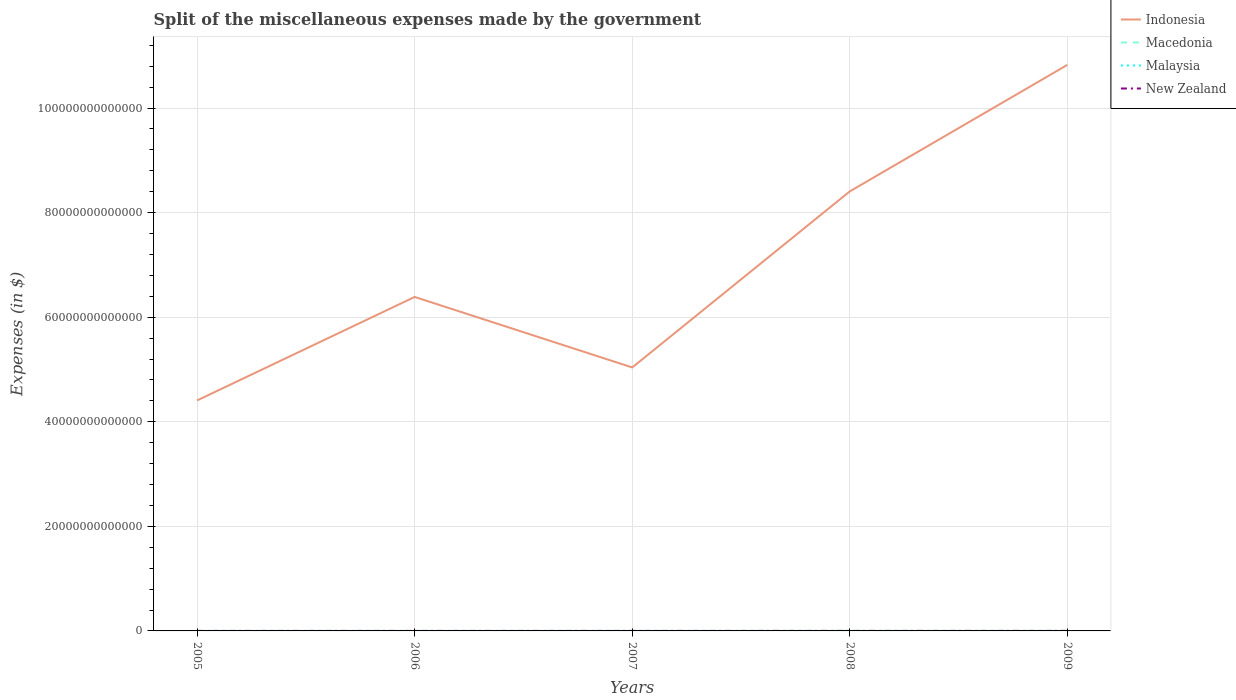Is the number of lines equal to the number of legend labels?
Make the answer very short. Yes. Across all years, what is the maximum miscellaneous expenses made by the government in New Zealand?
Your answer should be compact. 3.12e+09. In which year was the miscellaneous expenses made by the government in Macedonia maximum?
Ensure brevity in your answer.  2005. What is the total miscellaneous expenses made by the government in Indonesia in the graph?
Give a very brief answer. 1.35e+13. What is the difference between the highest and the second highest miscellaneous expenses made by the government in Malaysia?
Provide a succinct answer. 8.54e+08. How many lines are there?
Provide a short and direct response. 4. What is the difference between two consecutive major ticks on the Y-axis?
Give a very brief answer. 2.00e+13. What is the title of the graph?
Offer a terse response. Split of the miscellaneous expenses made by the government. What is the label or title of the Y-axis?
Offer a very short reply. Expenses (in $). What is the Expenses (in $) of Indonesia in 2005?
Give a very brief answer. 4.41e+13. What is the Expenses (in $) in Macedonia in 2005?
Make the answer very short. 2.39e+09. What is the Expenses (in $) of Malaysia in 2005?
Keep it short and to the point. 3.43e+08. What is the Expenses (in $) of New Zealand in 2005?
Ensure brevity in your answer.  3.12e+09. What is the Expenses (in $) in Indonesia in 2006?
Your answer should be very brief. 6.39e+13. What is the Expenses (in $) in Macedonia in 2006?
Offer a terse response. 2.82e+09. What is the Expenses (in $) in Malaysia in 2006?
Offer a very short reply. 3.91e+08. What is the Expenses (in $) in New Zealand in 2006?
Keep it short and to the point. 3.35e+09. What is the Expenses (in $) in Indonesia in 2007?
Provide a short and direct response. 5.04e+13. What is the Expenses (in $) in Macedonia in 2007?
Your response must be concise. 5.47e+09. What is the Expenses (in $) of Malaysia in 2007?
Your response must be concise. 1.20e+09. What is the Expenses (in $) of New Zealand in 2007?
Make the answer very short. 3.92e+09. What is the Expenses (in $) in Indonesia in 2008?
Your response must be concise. 8.41e+13. What is the Expenses (in $) in Macedonia in 2008?
Offer a terse response. 7.88e+09. What is the Expenses (in $) of Malaysia in 2008?
Your answer should be compact. 8.49e+08. What is the Expenses (in $) in New Zealand in 2008?
Ensure brevity in your answer.  4.79e+09. What is the Expenses (in $) of Indonesia in 2009?
Give a very brief answer. 1.08e+14. What is the Expenses (in $) of Macedonia in 2009?
Your response must be concise. 5.48e+09. What is the Expenses (in $) in Malaysia in 2009?
Provide a short and direct response. 6.85e+08. What is the Expenses (in $) in New Zealand in 2009?
Make the answer very short. 6.83e+09. Across all years, what is the maximum Expenses (in $) of Indonesia?
Provide a short and direct response. 1.08e+14. Across all years, what is the maximum Expenses (in $) in Macedonia?
Your answer should be compact. 7.88e+09. Across all years, what is the maximum Expenses (in $) of Malaysia?
Give a very brief answer. 1.20e+09. Across all years, what is the maximum Expenses (in $) of New Zealand?
Your answer should be compact. 6.83e+09. Across all years, what is the minimum Expenses (in $) of Indonesia?
Give a very brief answer. 4.41e+13. Across all years, what is the minimum Expenses (in $) in Macedonia?
Your answer should be very brief. 2.39e+09. Across all years, what is the minimum Expenses (in $) of Malaysia?
Offer a terse response. 3.43e+08. Across all years, what is the minimum Expenses (in $) of New Zealand?
Provide a succinct answer. 3.12e+09. What is the total Expenses (in $) of Indonesia in the graph?
Make the answer very short. 3.51e+14. What is the total Expenses (in $) of Macedonia in the graph?
Keep it short and to the point. 2.40e+1. What is the total Expenses (in $) of Malaysia in the graph?
Ensure brevity in your answer.  3.47e+09. What is the total Expenses (in $) of New Zealand in the graph?
Provide a succinct answer. 2.20e+1. What is the difference between the Expenses (in $) in Indonesia in 2005 and that in 2006?
Provide a succinct answer. -1.98e+13. What is the difference between the Expenses (in $) in Macedonia in 2005 and that in 2006?
Provide a short and direct response. -4.32e+08. What is the difference between the Expenses (in $) of Malaysia in 2005 and that in 2006?
Offer a terse response. -4.78e+07. What is the difference between the Expenses (in $) of New Zealand in 2005 and that in 2006?
Provide a succinct answer. -2.37e+08. What is the difference between the Expenses (in $) in Indonesia in 2005 and that in 2007?
Provide a succinct answer. -6.31e+12. What is the difference between the Expenses (in $) in Macedonia in 2005 and that in 2007?
Give a very brief answer. -3.08e+09. What is the difference between the Expenses (in $) of Malaysia in 2005 and that in 2007?
Your response must be concise. -8.54e+08. What is the difference between the Expenses (in $) of New Zealand in 2005 and that in 2007?
Make the answer very short. -8.05e+08. What is the difference between the Expenses (in $) in Indonesia in 2005 and that in 2008?
Provide a short and direct response. -4.00e+13. What is the difference between the Expenses (in $) in Macedonia in 2005 and that in 2008?
Your answer should be compact. -5.49e+09. What is the difference between the Expenses (in $) of Malaysia in 2005 and that in 2008?
Ensure brevity in your answer.  -5.06e+08. What is the difference between the Expenses (in $) in New Zealand in 2005 and that in 2008?
Your response must be concise. -1.68e+09. What is the difference between the Expenses (in $) of Indonesia in 2005 and that in 2009?
Provide a succinct answer. -6.42e+13. What is the difference between the Expenses (in $) in Macedonia in 2005 and that in 2009?
Provide a succinct answer. -3.09e+09. What is the difference between the Expenses (in $) of Malaysia in 2005 and that in 2009?
Give a very brief answer. -3.42e+08. What is the difference between the Expenses (in $) of New Zealand in 2005 and that in 2009?
Keep it short and to the point. -3.71e+09. What is the difference between the Expenses (in $) in Indonesia in 2006 and that in 2007?
Keep it short and to the point. 1.35e+13. What is the difference between the Expenses (in $) of Macedonia in 2006 and that in 2007?
Give a very brief answer. -2.65e+09. What is the difference between the Expenses (in $) of Malaysia in 2006 and that in 2007?
Your answer should be compact. -8.07e+08. What is the difference between the Expenses (in $) of New Zealand in 2006 and that in 2007?
Your answer should be very brief. -5.68e+08. What is the difference between the Expenses (in $) in Indonesia in 2006 and that in 2008?
Offer a terse response. -2.02e+13. What is the difference between the Expenses (in $) of Macedonia in 2006 and that in 2008?
Offer a terse response. -5.06e+09. What is the difference between the Expenses (in $) of Malaysia in 2006 and that in 2008?
Give a very brief answer. -4.58e+08. What is the difference between the Expenses (in $) of New Zealand in 2006 and that in 2008?
Ensure brevity in your answer.  -1.44e+09. What is the difference between the Expenses (in $) of Indonesia in 2006 and that in 2009?
Make the answer very short. -4.44e+13. What is the difference between the Expenses (in $) of Macedonia in 2006 and that in 2009?
Offer a terse response. -2.66e+09. What is the difference between the Expenses (in $) of Malaysia in 2006 and that in 2009?
Your answer should be compact. -2.94e+08. What is the difference between the Expenses (in $) in New Zealand in 2006 and that in 2009?
Your answer should be compact. -3.48e+09. What is the difference between the Expenses (in $) in Indonesia in 2007 and that in 2008?
Your answer should be very brief. -3.37e+13. What is the difference between the Expenses (in $) of Macedonia in 2007 and that in 2008?
Ensure brevity in your answer.  -2.41e+09. What is the difference between the Expenses (in $) of Malaysia in 2007 and that in 2008?
Your answer should be very brief. 3.48e+08. What is the difference between the Expenses (in $) of New Zealand in 2007 and that in 2008?
Your response must be concise. -8.73e+08. What is the difference between the Expenses (in $) of Indonesia in 2007 and that in 2009?
Your answer should be very brief. -5.79e+13. What is the difference between the Expenses (in $) of Macedonia in 2007 and that in 2009?
Provide a short and direct response. -1.40e+07. What is the difference between the Expenses (in $) of Malaysia in 2007 and that in 2009?
Keep it short and to the point. 5.12e+08. What is the difference between the Expenses (in $) in New Zealand in 2007 and that in 2009?
Make the answer very short. -2.91e+09. What is the difference between the Expenses (in $) in Indonesia in 2008 and that in 2009?
Your answer should be compact. -2.42e+13. What is the difference between the Expenses (in $) in Macedonia in 2008 and that in 2009?
Provide a short and direct response. 2.40e+09. What is the difference between the Expenses (in $) in Malaysia in 2008 and that in 2009?
Offer a terse response. 1.64e+08. What is the difference between the Expenses (in $) of New Zealand in 2008 and that in 2009?
Your answer should be very brief. -2.04e+09. What is the difference between the Expenses (in $) of Indonesia in 2005 and the Expenses (in $) of Macedonia in 2006?
Your response must be concise. 4.41e+13. What is the difference between the Expenses (in $) in Indonesia in 2005 and the Expenses (in $) in Malaysia in 2006?
Your response must be concise. 4.41e+13. What is the difference between the Expenses (in $) of Indonesia in 2005 and the Expenses (in $) of New Zealand in 2006?
Your response must be concise. 4.41e+13. What is the difference between the Expenses (in $) in Macedonia in 2005 and the Expenses (in $) in Malaysia in 2006?
Make the answer very short. 2.00e+09. What is the difference between the Expenses (in $) in Macedonia in 2005 and the Expenses (in $) in New Zealand in 2006?
Offer a terse response. -9.66e+08. What is the difference between the Expenses (in $) in Malaysia in 2005 and the Expenses (in $) in New Zealand in 2006?
Offer a terse response. -3.01e+09. What is the difference between the Expenses (in $) of Indonesia in 2005 and the Expenses (in $) of Macedonia in 2007?
Offer a very short reply. 4.41e+13. What is the difference between the Expenses (in $) in Indonesia in 2005 and the Expenses (in $) in Malaysia in 2007?
Offer a very short reply. 4.41e+13. What is the difference between the Expenses (in $) in Indonesia in 2005 and the Expenses (in $) in New Zealand in 2007?
Keep it short and to the point. 4.41e+13. What is the difference between the Expenses (in $) in Macedonia in 2005 and the Expenses (in $) in Malaysia in 2007?
Your answer should be compact. 1.19e+09. What is the difference between the Expenses (in $) in Macedonia in 2005 and the Expenses (in $) in New Zealand in 2007?
Give a very brief answer. -1.53e+09. What is the difference between the Expenses (in $) in Malaysia in 2005 and the Expenses (in $) in New Zealand in 2007?
Keep it short and to the point. -3.58e+09. What is the difference between the Expenses (in $) of Indonesia in 2005 and the Expenses (in $) of Macedonia in 2008?
Provide a short and direct response. 4.41e+13. What is the difference between the Expenses (in $) of Indonesia in 2005 and the Expenses (in $) of Malaysia in 2008?
Keep it short and to the point. 4.41e+13. What is the difference between the Expenses (in $) in Indonesia in 2005 and the Expenses (in $) in New Zealand in 2008?
Provide a short and direct response. 4.41e+13. What is the difference between the Expenses (in $) in Macedonia in 2005 and the Expenses (in $) in Malaysia in 2008?
Provide a succinct answer. 1.54e+09. What is the difference between the Expenses (in $) in Macedonia in 2005 and the Expenses (in $) in New Zealand in 2008?
Offer a terse response. -2.41e+09. What is the difference between the Expenses (in $) of Malaysia in 2005 and the Expenses (in $) of New Zealand in 2008?
Make the answer very short. -4.45e+09. What is the difference between the Expenses (in $) in Indonesia in 2005 and the Expenses (in $) in Macedonia in 2009?
Ensure brevity in your answer.  4.41e+13. What is the difference between the Expenses (in $) of Indonesia in 2005 and the Expenses (in $) of Malaysia in 2009?
Provide a short and direct response. 4.41e+13. What is the difference between the Expenses (in $) in Indonesia in 2005 and the Expenses (in $) in New Zealand in 2009?
Your answer should be compact. 4.41e+13. What is the difference between the Expenses (in $) in Macedonia in 2005 and the Expenses (in $) in Malaysia in 2009?
Keep it short and to the point. 1.70e+09. What is the difference between the Expenses (in $) in Macedonia in 2005 and the Expenses (in $) in New Zealand in 2009?
Keep it short and to the point. -4.44e+09. What is the difference between the Expenses (in $) in Malaysia in 2005 and the Expenses (in $) in New Zealand in 2009?
Your answer should be compact. -6.49e+09. What is the difference between the Expenses (in $) of Indonesia in 2006 and the Expenses (in $) of Macedonia in 2007?
Offer a terse response. 6.39e+13. What is the difference between the Expenses (in $) in Indonesia in 2006 and the Expenses (in $) in Malaysia in 2007?
Provide a succinct answer. 6.39e+13. What is the difference between the Expenses (in $) in Indonesia in 2006 and the Expenses (in $) in New Zealand in 2007?
Your answer should be compact. 6.39e+13. What is the difference between the Expenses (in $) of Macedonia in 2006 and the Expenses (in $) of Malaysia in 2007?
Offer a terse response. 1.62e+09. What is the difference between the Expenses (in $) in Macedonia in 2006 and the Expenses (in $) in New Zealand in 2007?
Offer a very short reply. -1.10e+09. What is the difference between the Expenses (in $) of Malaysia in 2006 and the Expenses (in $) of New Zealand in 2007?
Ensure brevity in your answer.  -3.53e+09. What is the difference between the Expenses (in $) in Indonesia in 2006 and the Expenses (in $) in Macedonia in 2008?
Provide a succinct answer. 6.39e+13. What is the difference between the Expenses (in $) of Indonesia in 2006 and the Expenses (in $) of Malaysia in 2008?
Offer a very short reply. 6.39e+13. What is the difference between the Expenses (in $) of Indonesia in 2006 and the Expenses (in $) of New Zealand in 2008?
Your response must be concise. 6.39e+13. What is the difference between the Expenses (in $) in Macedonia in 2006 and the Expenses (in $) in Malaysia in 2008?
Provide a succinct answer. 1.97e+09. What is the difference between the Expenses (in $) in Macedonia in 2006 and the Expenses (in $) in New Zealand in 2008?
Provide a succinct answer. -1.97e+09. What is the difference between the Expenses (in $) of Malaysia in 2006 and the Expenses (in $) of New Zealand in 2008?
Make the answer very short. -4.40e+09. What is the difference between the Expenses (in $) of Indonesia in 2006 and the Expenses (in $) of Macedonia in 2009?
Your answer should be compact. 6.39e+13. What is the difference between the Expenses (in $) in Indonesia in 2006 and the Expenses (in $) in Malaysia in 2009?
Your response must be concise. 6.39e+13. What is the difference between the Expenses (in $) of Indonesia in 2006 and the Expenses (in $) of New Zealand in 2009?
Provide a short and direct response. 6.39e+13. What is the difference between the Expenses (in $) in Macedonia in 2006 and the Expenses (in $) in Malaysia in 2009?
Your response must be concise. 2.13e+09. What is the difference between the Expenses (in $) in Macedonia in 2006 and the Expenses (in $) in New Zealand in 2009?
Make the answer very short. -4.01e+09. What is the difference between the Expenses (in $) of Malaysia in 2006 and the Expenses (in $) of New Zealand in 2009?
Provide a short and direct response. -6.44e+09. What is the difference between the Expenses (in $) of Indonesia in 2007 and the Expenses (in $) of Macedonia in 2008?
Provide a succinct answer. 5.04e+13. What is the difference between the Expenses (in $) in Indonesia in 2007 and the Expenses (in $) in Malaysia in 2008?
Give a very brief answer. 5.04e+13. What is the difference between the Expenses (in $) in Indonesia in 2007 and the Expenses (in $) in New Zealand in 2008?
Keep it short and to the point. 5.04e+13. What is the difference between the Expenses (in $) in Macedonia in 2007 and the Expenses (in $) in Malaysia in 2008?
Provide a short and direct response. 4.62e+09. What is the difference between the Expenses (in $) of Macedonia in 2007 and the Expenses (in $) of New Zealand in 2008?
Provide a succinct answer. 6.73e+08. What is the difference between the Expenses (in $) of Malaysia in 2007 and the Expenses (in $) of New Zealand in 2008?
Offer a terse response. -3.60e+09. What is the difference between the Expenses (in $) in Indonesia in 2007 and the Expenses (in $) in Macedonia in 2009?
Provide a succinct answer. 5.04e+13. What is the difference between the Expenses (in $) of Indonesia in 2007 and the Expenses (in $) of Malaysia in 2009?
Offer a terse response. 5.04e+13. What is the difference between the Expenses (in $) in Indonesia in 2007 and the Expenses (in $) in New Zealand in 2009?
Offer a terse response. 5.04e+13. What is the difference between the Expenses (in $) in Macedonia in 2007 and the Expenses (in $) in Malaysia in 2009?
Provide a succinct answer. 4.78e+09. What is the difference between the Expenses (in $) in Macedonia in 2007 and the Expenses (in $) in New Zealand in 2009?
Offer a terse response. -1.36e+09. What is the difference between the Expenses (in $) of Malaysia in 2007 and the Expenses (in $) of New Zealand in 2009?
Your answer should be very brief. -5.63e+09. What is the difference between the Expenses (in $) in Indonesia in 2008 and the Expenses (in $) in Macedonia in 2009?
Your answer should be very brief. 8.41e+13. What is the difference between the Expenses (in $) of Indonesia in 2008 and the Expenses (in $) of Malaysia in 2009?
Your response must be concise. 8.41e+13. What is the difference between the Expenses (in $) in Indonesia in 2008 and the Expenses (in $) in New Zealand in 2009?
Make the answer very short. 8.41e+13. What is the difference between the Expenses (in $) of Macedonia in 2008 and the Expenses (in $) of Malaysia in 2009?
Your response must be concise. 7.19e+09. What is the difference between the Expenses (in $) of Macedonia in 2008 and the Expenses (in $) of New Zealand in 2009?
Your answer should be very brief. 1.05e+09. What is the difference between the Expenses (in $) in Malaysia in 2008 and the Expenses (in $) in New Zealand in 2009?
Offer a terse response. -5.98e+09. What is the average Expenses (in $) of Indonesia per year?
Make the answer very short. 7.01e+13. What is the average Expenses (in $) in Macedonia per year?
Provide a short and direct response. 4.81e+09. What is the average Expenses (in $) of Malaysia per year?
Your answer should be very brief. 6.93e+08. What is the average Expenses (in $) of New Zealand per year?
Offer a very short reply. 4.40e+09. In the year 2005, what is the difference between the Expenses (in $) of Indonesia and Expenses (in $) of Macedonia?
Offer a terse response. 4.41e+13. In the year 2005, what is the difference between the Expenses (in $) in Indonesia and Expenses (in $) in Malaysia?
Keep it short and to the point. 4.41e+13. In the year 2005, what is the difference between the Expenses (in $) in Indonesia and Expenses (in $) in New Zealand?
Provide a succinct answer. 4.41e+13. In the year 2005, what is the difference between the Expenses (in $) of Macedonia and Expenses (in $) of Malaysia?
Provide a succinct answer. 2.04e+09. In the year 2005, what is the difference between the Expenses (in $) in Macedonia and Expenses (in $) in New Zealand?
Offer a very short reply. -7.29e+08. In the year 2005, what is the difference between the Expenses (in $) of Malaysia and Expenses (in $) of New Zealand?
Give a very brief answer. -2.77e+09. In the year 2006, what is the difference between the Expenses (in $) of Indonesia and Expenses (in $) of Macedonia?
Give a very brief answer. 6.39e+13. In the year 2006, what is the difference between the Expenses (in $) in Indonesia and Expenses (in $) in Malaysia?
Provide a succinct answer. 6.39e+13. In the year 2006, what is the difference between the Expenses (in $) in Indonesia and Expenses (in $) in New Zealand?
Give a very brief answer. 6.39e+13. In the year 2006, what is the difference between the Expenses (in $) of Macedonia and Expenses (in $) of Malaysia?
Provide a succinct answer. 2.43e+09. In the year 2006, what is the difference between the Expenses (in $) in Macedonia and Expenses (in $) in New Zealand?
Provide a short and direct response. -5.33e+08. In the year 2006, what is the difference between the Expenses (in $) of Malaysia and Expenses (in $) of New Zealand?
Your answer should be compact. -2.96e+09. In the year 2007, what is the difference between the Expenses (in $) in Indonesia and Expenses (in $) in Macedonia?
Make the answer very short. 5.04e+13. In the year 2007, what is the difference between the Expenses (in $) in Indonesia and Expenses (in $) in Malaysia?
Provide a succinct answer. 5.04e+13. In the year 2007, what is the difference between the Expenses (in $) in Indonesia and Expenses (in $) in New Zealand?
Provide a short and direct response. 5.04e+13. In the year 2007, what is the difference between the Expenses (in $) in Macedonia and Expenses (in $) in Malaysia?
Ensure brevity in your answer.  4.27e+09. In the year 2007, what is the difference between the Expenses (in $) of Macedonia and Expenses (in $) of New Zealand?
Provide a succinct answer. 1.55e+09. In the year 2007, what is the difference between the Expenses (in $) of Malaysia and Expenses (in $) of New Zealand?
Provide a succinct answer. -2.72e+09. In the year 2008, what is the difference between the Expenses (in $) in Indonesia and Expenses (in $) in Macedonia?
Provide a succinct answer. 8.41e+13. In the year 2008, what is the difference between the Expenses (in $) in Indonesia and Expenses (in $) in Malaysia?
Your answer should be very brief. 8.41e+13. In the year 2008, what is the difference between the Expenses (in $) in Indonesia and Expenses (in $) in New Zealand?
Offer a terse response. 8.41e+13. In the year 2008, what is the difference between the Expenses (in $) of Macedonia and Expenses (in $) of Malaysia?
Ensure brevity in your answer.  7.03e+09. In the year 2008, what is the difference between the Expenses (in $) of Macedonia and Expenses (in $) of New Zealand?
Your answer should be compact. 3.08e+09. In the year 2008, what is the difference between the Expenses (in $) of Malaysia and Expenses (in $) of New Zealand?
Your answer should be compact. -3.94e+09. In the year 2009, what is the difference between the Expenses (in $) in Indonesia and Expenses (in $) in Macedonia?
Make the answer very short. 1.08e+14. In the year 2009, what is the difference between the Expenses (in $) in Indonesia and Expenses (in $) in Malaysia?
Keep it short and to the point. 1.08e+14. In the year 2009, what is the difference between the Expenses (in $) in Indonesia and Expenses (in $) in New Zealand?
Make the answer very short. 1.08e+14. In the year 2009, what is the difference between the Expenses (in $) in Macedonia and Expenses (in $) in Malaysia?
Make the answer very short. 4.80e+09. In the year 2009, what is the difference between the Expenses (in $) of Macedonia and Expenses (in $) of New Zealand?
Make the answer very short. -1.35e+09. In the year 2009, what is the difference between the Expenses (in $) of Malaysia and Expenses (in $) of New Zealand?
Provide a short and direct response. -6.14e+09. What is the ratio of the Expenses (in $) of Indonesia in 2005 to that in 2006?
Your answer should be very brief. 0.69. What is the ratio of the Expenses (in $) in Macedonia in 2005 to that in 2006?
Provide a succinct answer. 0.85. What is the ratio of the Expenses (in $) of Malaysia in 2005 to that in 2006?
Keep it short and to the point. 0.88. What is the ratio of the Expenses (in $) of New Zealand in 2005 to that in 2006?
Provide a short and direct response. 0.93. What is the ratio of the Expenses (in $) in Indonesia in 2005 to that in 2007?
Make the answer very short. 0.87. What is the ratio of the Expenses (in $) of Macedonia in 2005 to that in 2007?
Your answer should be very brief. 0.44. What is the ratio of the Expenses (in $) in Malaysia in 2005 to that in 2007?
Your answer should be compact. 0.29. What is the ratio of the Expenses (in $) of New Zealand in 2005 to that in 2007?
Offer a terse response. 0.79. What is the ratio of the Expenses (in $) in Indonesia in 2005 to that in 2008?
Your answer should be compact. 0.52. What is the ratio of the Expenses (in $) of Macedonia in 2005 to that in 2008?
Offer a very short reply. 0.3. What is the ratio of the Expenses (in $) of Malaysia in 2005 to that in 2008?
Your response must be concise. 0.4. What is the ratio of the Expenses (in $) of New Zealand in 2005 to that in 2008?
Your answer should be very brief. 0.65. What is the ratio of the Expenses (in $) in Indonesia in 2005 to that in 2009?
Offer a terse response. 0.41. What is the ratio of the Expenses (in $) of Macedonia in 2005 to that in 2009?
Offer a very short reply. 0.44. What is the ratio of the Expenses (in $) in Malaysia in 2005 to that in 2009?
Offer a terse response. 0.5. What is the ratio of the Expenses (in $) of New Zealand in 2005 to that in 2009?
Your answer should be compact. 0.46. What is the ratio of the Expenses (in $) of Indonesia in 2006 to that in 2007?
Provide a short and direct response. 1.27. What is the ratio of the Expenses (in $) in Macedonia in 2006 to that in 2007?
Your response must be concise. 0.52. What is the ratio of the Expenses (in $) in Malaysia in 2006 to that in 2007?
Ensure brevity in your answer.  0.33. What is the ratio of the Expenses (in $) of New Zealand in 2006 to that in 2007?
Provide a short and direct response. 0.86. What is the ratio of the Expenses (in $) in Indonesia in 2006 to that in 2008?
Make the answer very short. 0.76. What is the ratio of the Expenses (in $) of Macedonia in 2006 to that in 2008?
Ensure brevity in your answer.  0.36. What is the ratio of the Expenses (in $) in Malaysia in 2006 to that in 2008?
Offer a terse response. 0.46. What is the ratio of the Expenses (in $) of New Zealand in 2006 to that in 2008?
Ensure brevity in your answer.  0.7. What is the ratio of the Expenses (in $) in Indonesia in 2006 to that in 2009?
Provide a succinct answer. 0.59. What is the ratio of the Expenses (in $) of Macedonia in 2006 to that in 2009?
Offer a terse response. 0.51. What is the ratio of the Expenses (in $) in Malaysia in 2006 to that in 2009?
Offer a very short reply. 0.57. What is the ratio of the Expenses (in $) of New Zealand in 2006 to that in 2009?
Your response must be concise. 0.49. What is the ratio of the Expenses (in $) in Indonesia in 2007 to that in 2008?
Provide a short and direct response. 0.6. What is the ratio of the Expenses (in $) in Macedonia in 2007 to that in 2008?
Your answer should be compact. 0.69. What is the ratio of the Expenses (in $) in Malaysia in 2007 to that in 2008?
Make the answer very short. 1.41. What is the ratio of the Expenses (in $) of New Zealand in 2007 to that in 2008?
Provide a succinct answer. 0.82. What is the ratio of the Expenses (in $) of Indonesia in 2007 to that in 2009?
Provide a short and direct response. 0.47. What is the ratio of the Expenses (in $) in Malaysia in 2007 to that in 2009?
Keep it short and to the point. 1.75. What is the ratio of the Expenses (in $) of New Zealand in 2007 to that in 2009?
Ensure brevity in your answer.  0.57. What is the ratio of the Expenses (in $) of Indonesia in 2008 to that in 2009?
Ensure brevity in your answer.  0.78. What is the ratio of the Expenses (in $) of Macedonia in 2008 to that in 2009?
Your response must be concise. 1.44. What is the ratio of the Expenses (in $) of Malaysia in 2008 to that in 2009?
Your answer should be compact. 1.24. What is the ratio of the Expenses (in $) in New Zealand in 2008 to that in 2009?
Provide a succinct answer. 0.7. What is the difference between the highest and the second highest Expenses (in $) in Indonesia?
Your answer should be compact. 2.42e+13. What is the difference between the highest and the second highest Expenses (in $) of Macedonia?
Keep it short and to the point. 2.40e+09. What is the difference between the highest and the second highest Expenses (in $) in Malaysia?
Offer a terse response. 3.48e+08. What is the difference between the highest and the second highest Expenses (in $) of New Zealand?
Offer a very short reply. 2.04e+09. What is the difference between the highest and the lowest Expenses (in $) in Indonesia?
Make the answer very short. 6.42e+13. What is the difference between the highest and the lowest Expenses (in $) in Macedonia?
Make the answer very short. 5.49e+09. What is the difference between the highest and the lowest Expenses (in $) of Malaysia?
Ensure brevity in your answer.  8.54e+08. What is the difference between the highest and the lowest Expenses (in $) of New Zealand?
Your answer should be very brief. 3.71e+09. 